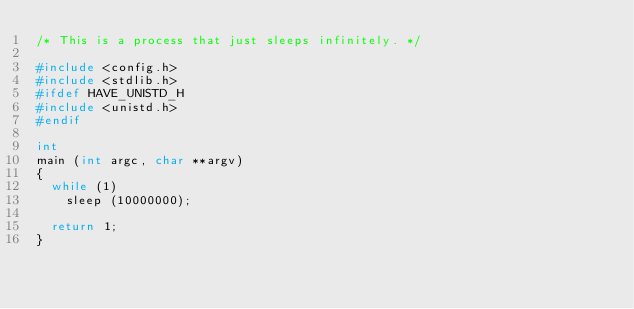Convert code to text. <code><loc_0><loc_0><loc_500><loc_500><_C_>/* This is a process that just sleeps infinitely. */

#include <config.h>
#include <stdlib.h>
#ifdef HAVE_UNISTD_H
#include <unistd.h>
#endif

int
main (int argc, char **argv)
{
  while (1)
    sleep (10000000);
  
  return 1;
}
</code> 